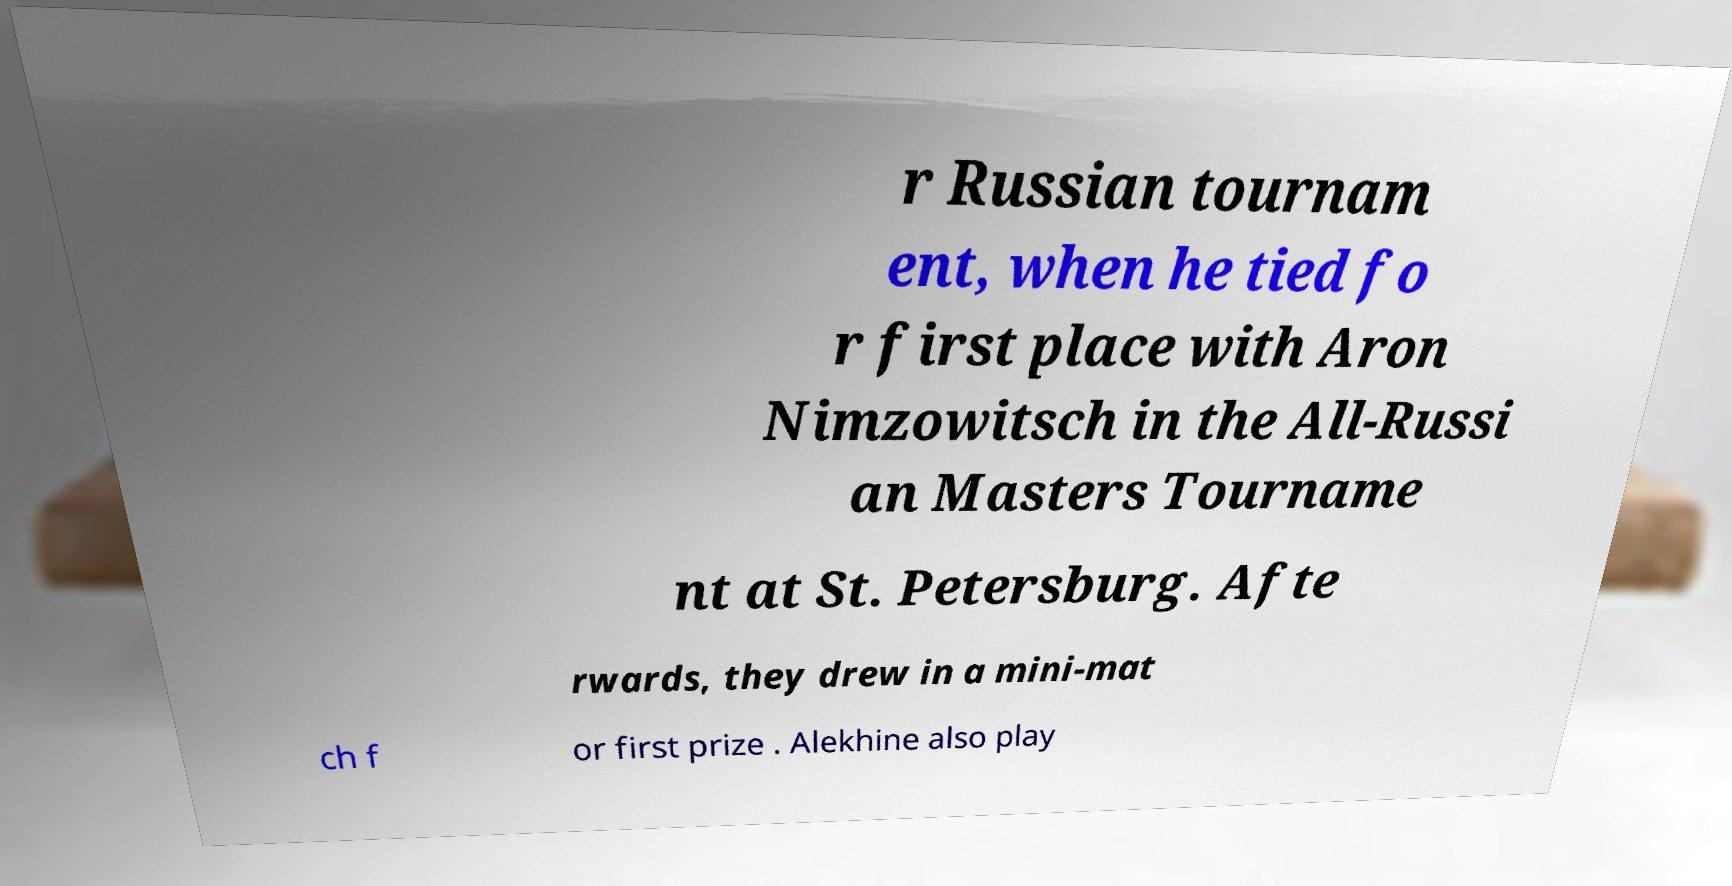Can you accurately transcribe the text from the provided image for me? r Russian tournam ent, when he tied fo r first place with Aron Nimzowitsch in the All-Russi an Masters Tourname nt at St. Petersburg. Afte rwards, they drew in a mini-mat ch f or first prize . Alekhine also play 